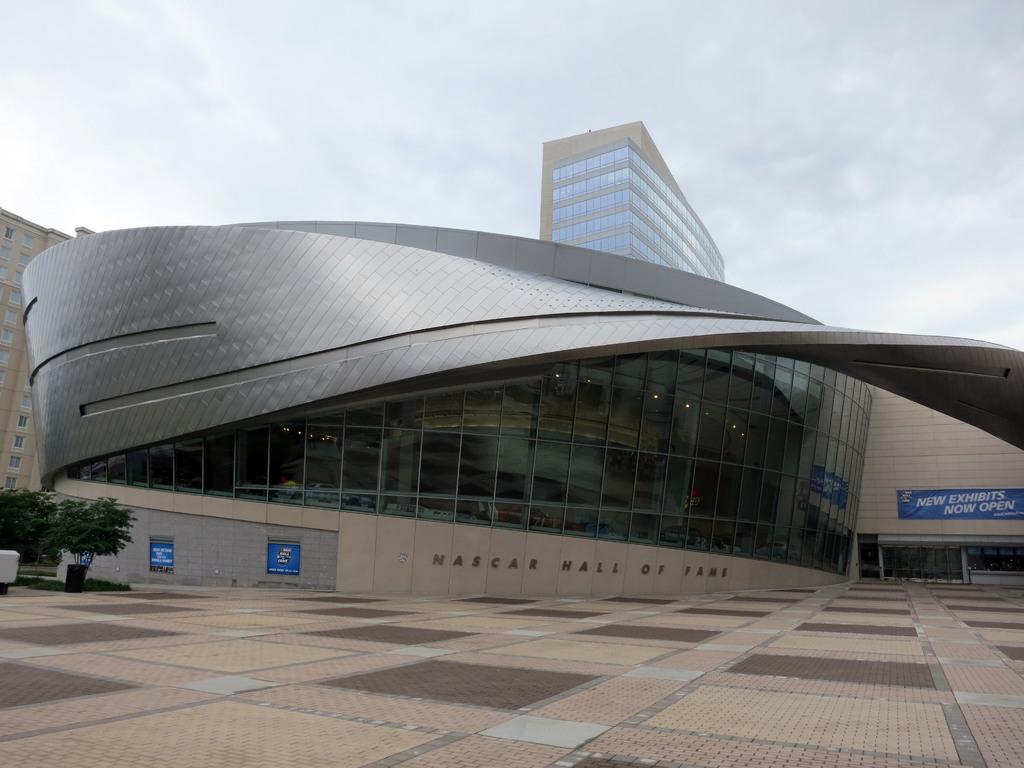What hall of fame is it?
Offer a very short reply. Nascar. 